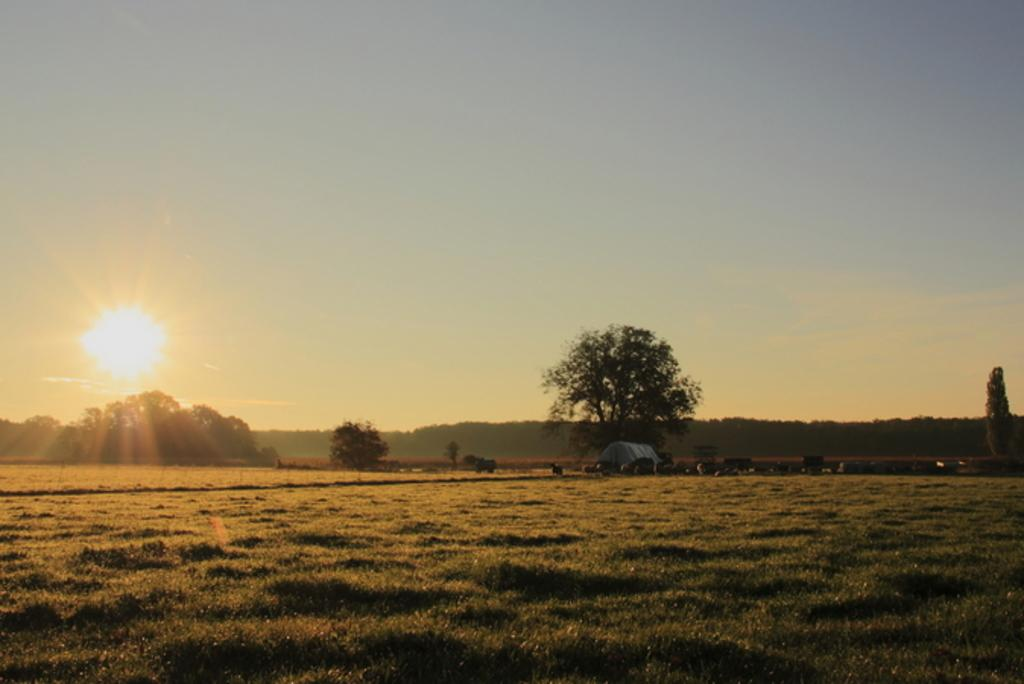What type of vegetation is present in the image? There is grass in the image. What other natural elements can be seen in the image? There are trees in the image. What type of structure is visible in the image? There appears to be a hut in the image. What is visible in the background of the image? The sky is visible in the background of the image. Can the sun be seen in the sky? Yes, the sun is observable in the sky. What songs are being sung by the leaves in the image? There are no leaves singing songs in the image; leaves are not capable of singing. 